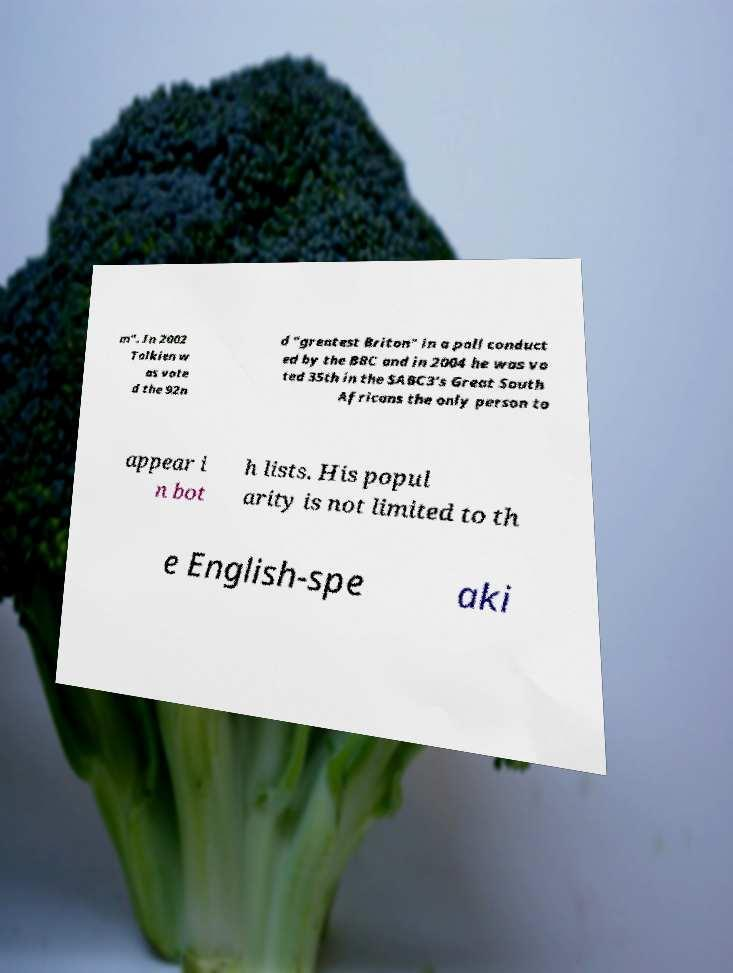Can you accurately transcribe the text from the provided image for me? m". In 2002 Tolkien w as vote d the 92n d "greatest Briton" in a poll conduct ed by the BBC and in 2004 he was vo ted 35th in the SABC3's Great South Africans the only person to appear i n bot h lists. His popul arity is not limited to th e English-spe aki 